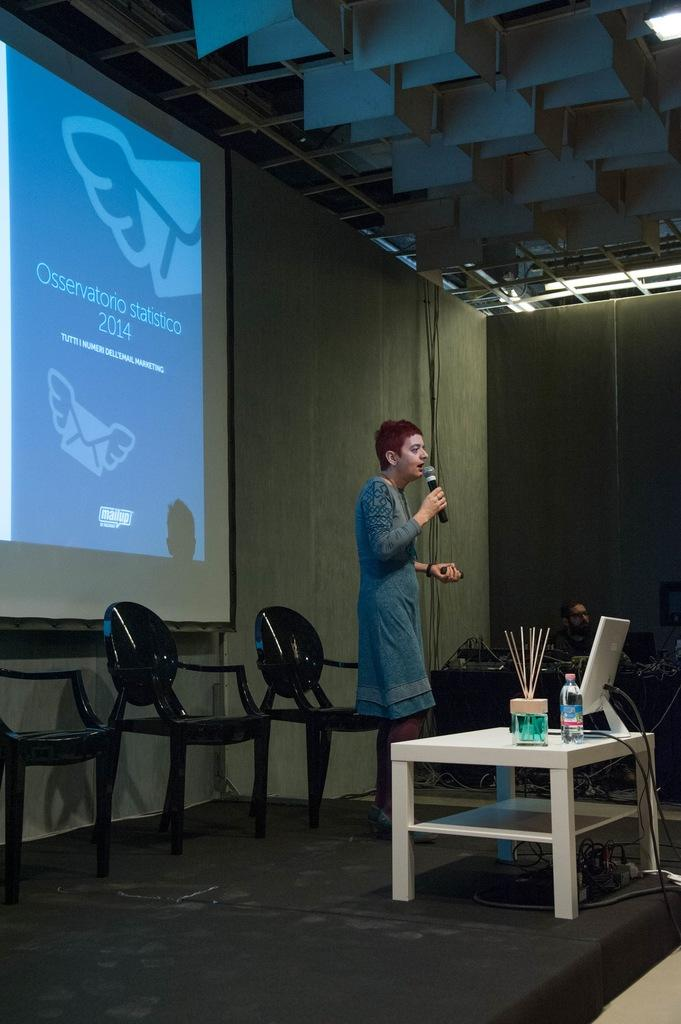<image>
Describe the image concisely. A lady is giving a presentation on statistics in 2014. 